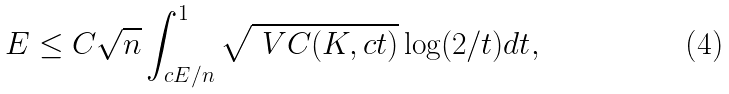<formula> <loc_0><loc_0><loc_500><loc_500>E \leq C \sqrt { n } \int _ { c E / n } ^ { 1 } \sqrt { \ V C ( K , c t ) } \log ( 2 / t ) d t ,</formula> 